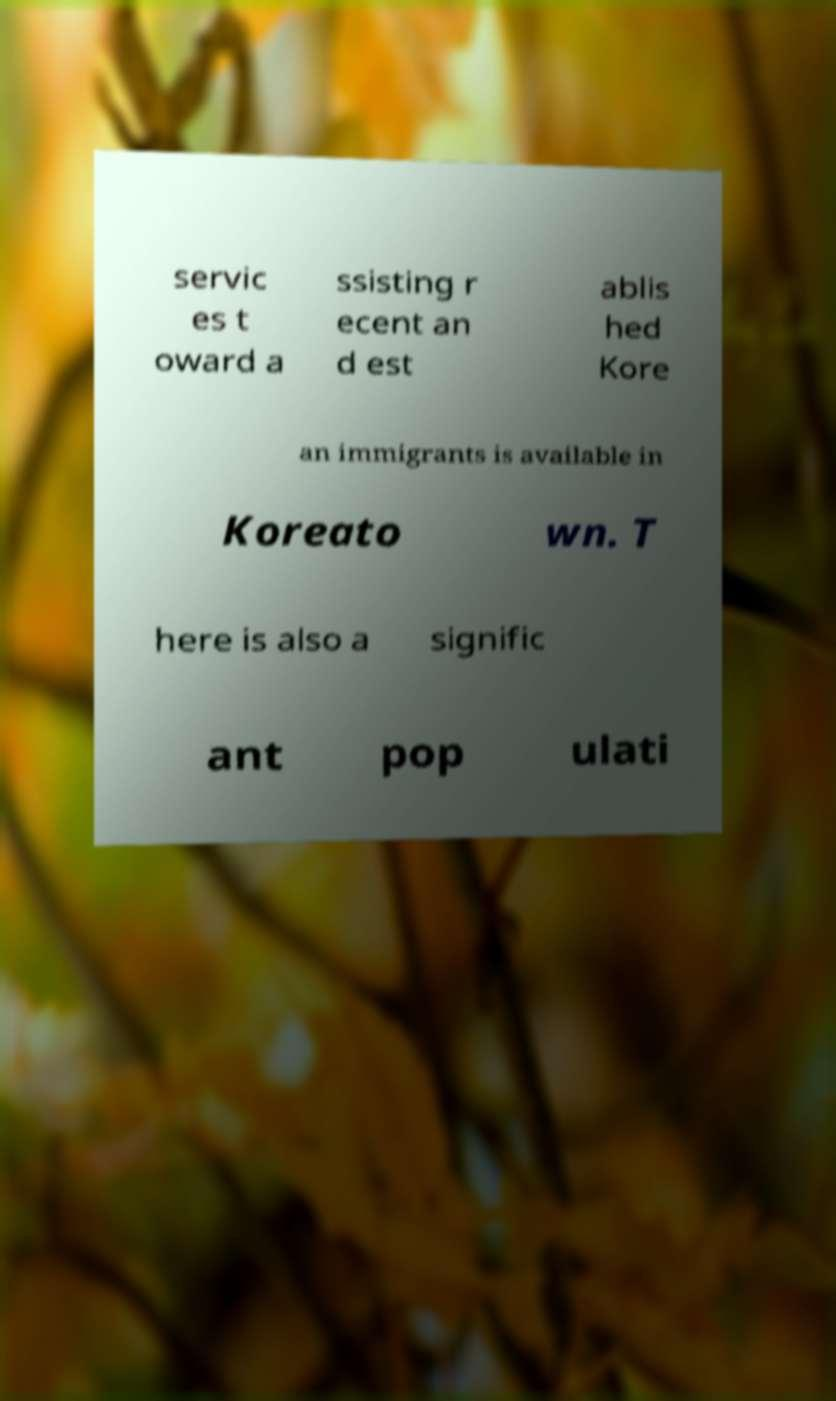Could you assist in decoding the text presented in this image and type it out clearly? servic es t oward a ssisting r ecent an d est ablis hed Kore an immigrants is available in Koreato wn. T here is also a signific ant pop ulati 